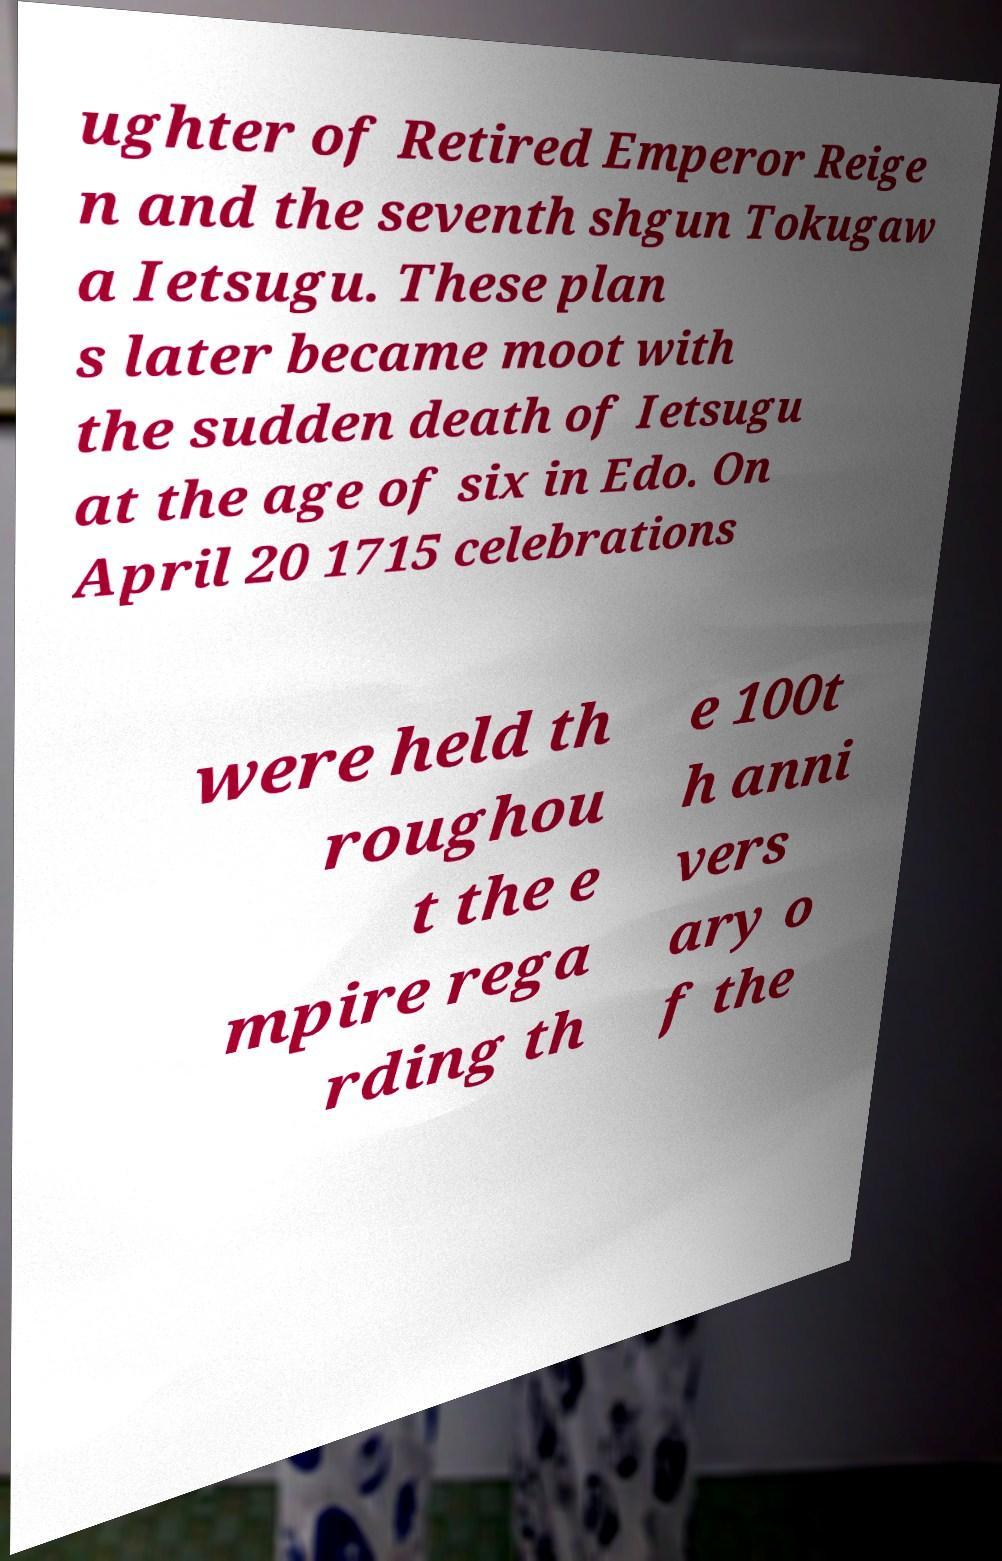For documentation purposes, I need the text within this image transcribed. Could you provide that? ughter of Retired Emperor Reige n and the seventh shgun Tokugaw a Ietsugu. These plan s later became moot with the sudden death of Ietsugu at the age of six in Edo. On April 20 1715 celebrations were held th roughou t the e mpire rega rding th e 100t h anni vers ary o f the 